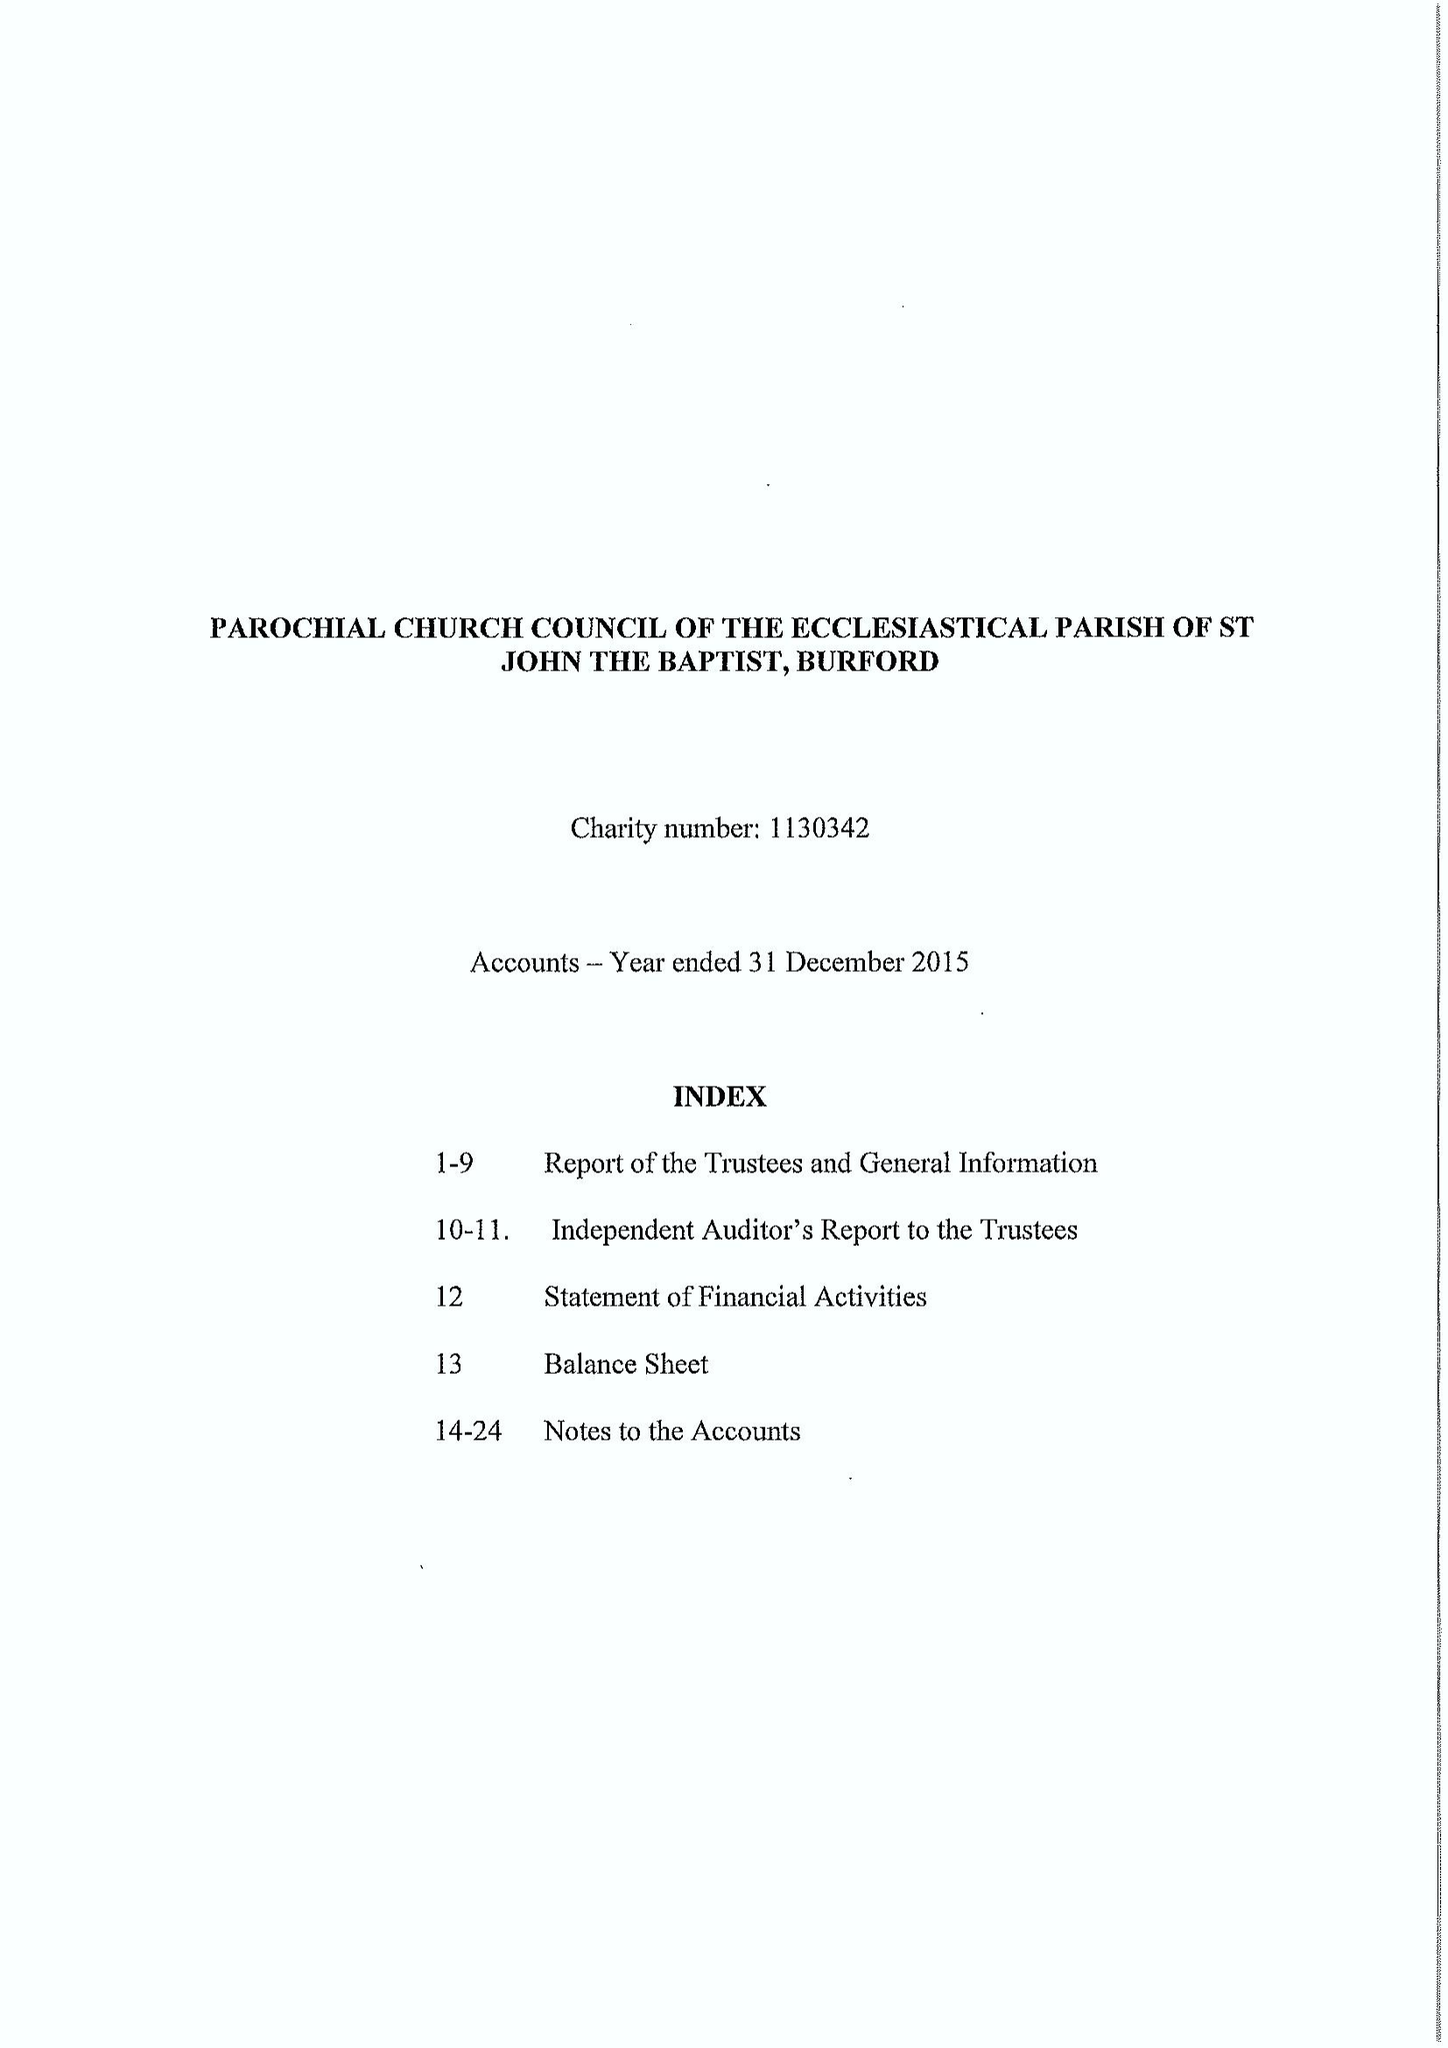What is the value for the address__post_town?
Answer the question using a single word or phrase. CARTERTON 